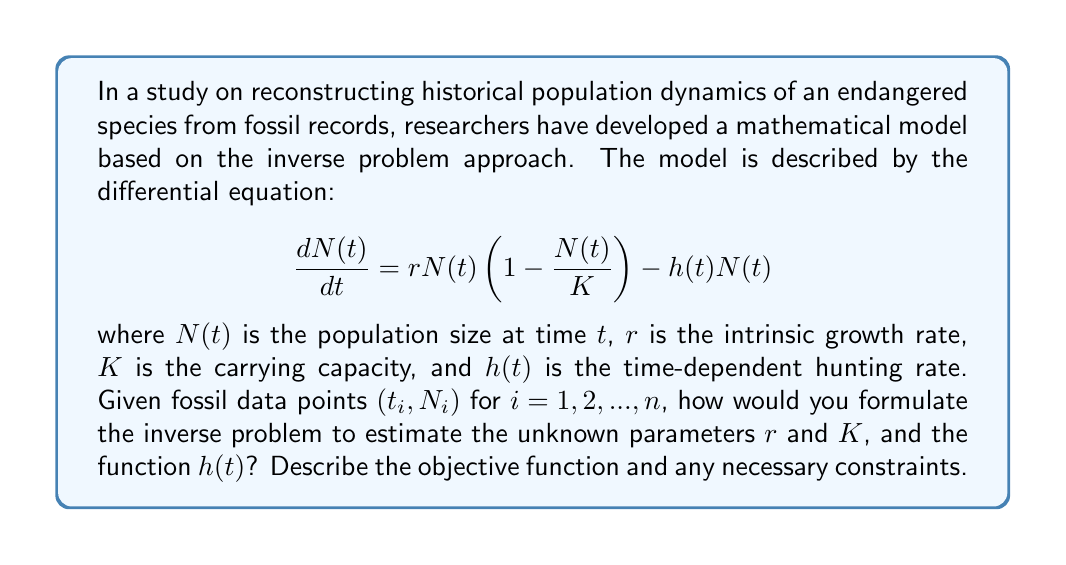Provide a solution to this math problem. To formulate the inverse problem for estimating the unknown parameters $r$ and $K$, and the function $h(t)$, we need to follow these steps:

1. Define the forward problem:
   The forward problem is given by the differential equation:
   $$\frac{dN(t)}{dt} = rN(t)\left(1 - \frac{N(t)}{K}\right) - h(t)N(t)$$

2. Discretize the problem:
   We have fossil data points $(t_i, N_i)$ for $i = 1, 2, ..., n$. We need to discretize the differential equation using a numerical method (e.g., Euler's method or Runge-Kutta).

3. Define the objective function:
   The objective function aims to minimize the difference between the observed fossil data and the model predictions. We can use the least squares method:
   $$J(r, K, h) = \sum_{i=1}^n (N_i - N(t_i; r, K, h))^2$$
   where $N(t_i; r, K, h)$ is the model prediction at time $t_i$ given parameters $r$, $K$, and function $h(t)$.

4. Add regularization terms:
   To ensure stability and avoid overfitting, we add regularization terms for $h(t)$:
   $$J_{reg}(r, K, h) = J(r, K, h) + \alpha\int_0^T |h'(t)|^2 dt + \beta\int_0^T |h(t)|^2 dt$$
   where $\alpha$ and $\beta$ are regularization parameters, and $T$ is the total time span.

5. Define constraints:
   We need to ensure that the parameters and function are biologically meaningful:
   $$r > 0, K > 0, h(t) \geq 0 \text{ for all } t$$

6. Formulate the inverse problem:
   The inverse problem can be stated as:
   $$\min_{r, K, h} J_{reg}(r, K, h)$$
   subject to the constraints mentioned in step 5.

7. Solve the inverse problem:
   Use optimization techniques such as gradient descent, conjugate gradient, or more advanced methods like the adjoint method to solve the minimization problem.

This formulation allows for the estimation of the unknown parameters $r$ and $K$, as well as the time-dependent hunting rate function $h(t)$, based on the available fossil data points.
Answer: Minimize $J_{reg}(r, K, h) = \sum_{i=1}^n (N_i - N(t_i; r, K, h))^2 + \alpha\int_0^T |h'(t)|^2 dt + \beta\int_0^T |h(t)|^2 dt$, subject to $r > 0$, $K > 0$, $h(t) \geq 0$. 